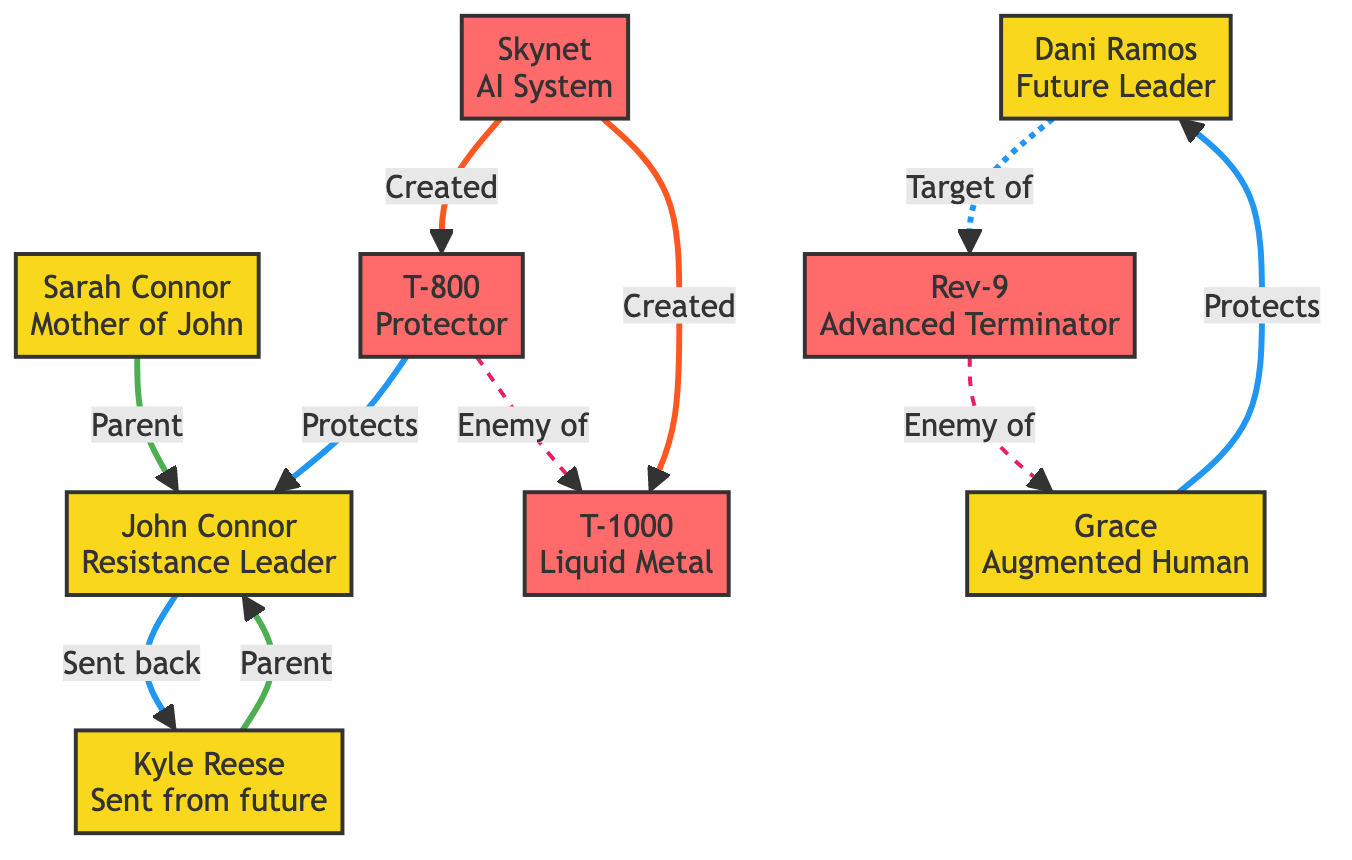What is the relationship between Sarah Connor and John Connor? In the diagram, there is a direct edge connecting Sarah Connor to John Connor labeled "Parent." This indicates that Sarah Connor is the parent of John Connor.
Answer: Parent How many characters are shown in the diagram? Upon examining the nodes in the diagram, there are a total of seven characters listed: Sarah Connor, John Connor, Kyle Reese, Dani Ramos, Grace, T-800, and T-1000.
Answer: Seven Who sent Kyle Reese back to protect Sarah Connor? The diagram indicates that John Connor is the one who sent Kyle Reese back to protect Sarah Connor, as shown by the directed edge labeled "Sent back to protect" from John Connor to Kyle Reese.
Answer: John Connor Which character is targeted by Rev-9? The relationships in the diagram indicate that Dani Ramos has a directed edge labeled "Target of" pointing towards Rev-9. This means that Rev-9 is sent to eliminate Dani Ramos.
Answer: Dani Ramos Who protects Dani Ramos? The diagram shows that Grace has a directed edge labeled "Protects" pointing to Dani Ramos. This indicates that Grace's role is to safeguard Dani Ramos from threats.
Answer: Grace What is the relationship between T-800 and T-1000? The diagram illustrates that T-800 is labeled as an "Enemy of" T-1000, indicating a hostile relationship between these two characters.
Answer: Enemy of How many artificial intelligence entities are present in the diagram? There are three distinct entities categorized as artificial intelligence: Skynet, T-800, and T-1000. Counting these nodes shows that there are three AI entities.
Answer: Three Which character was created by Skynet? According to the diagram, both T-800 and T-1000 have edges labeled "Created by" pointing to Skynet, thereby indicating that they were both created by this artificial intelligence system.
Answer: T-800, T-1000 Who is the future leader of the Resistance? In the diagram, Dani Ramos is identified as the character labeled "Future Leader" which signifies her importance in the Resistance within the narrative of the Terminator saga.
Answer: Dani Ramos 